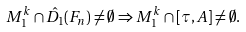<formula> <loc_0><loc_0><loc_500><loc_500>M ^ { k } _ { 1 } \cap \hat { D } _ { 1 } ( F _ { n } ) \ne \emptyset \Rightarrow M ^ { k } _ { 1 } \cap [ \tau , A ] \ne \emptyset .</formula> 